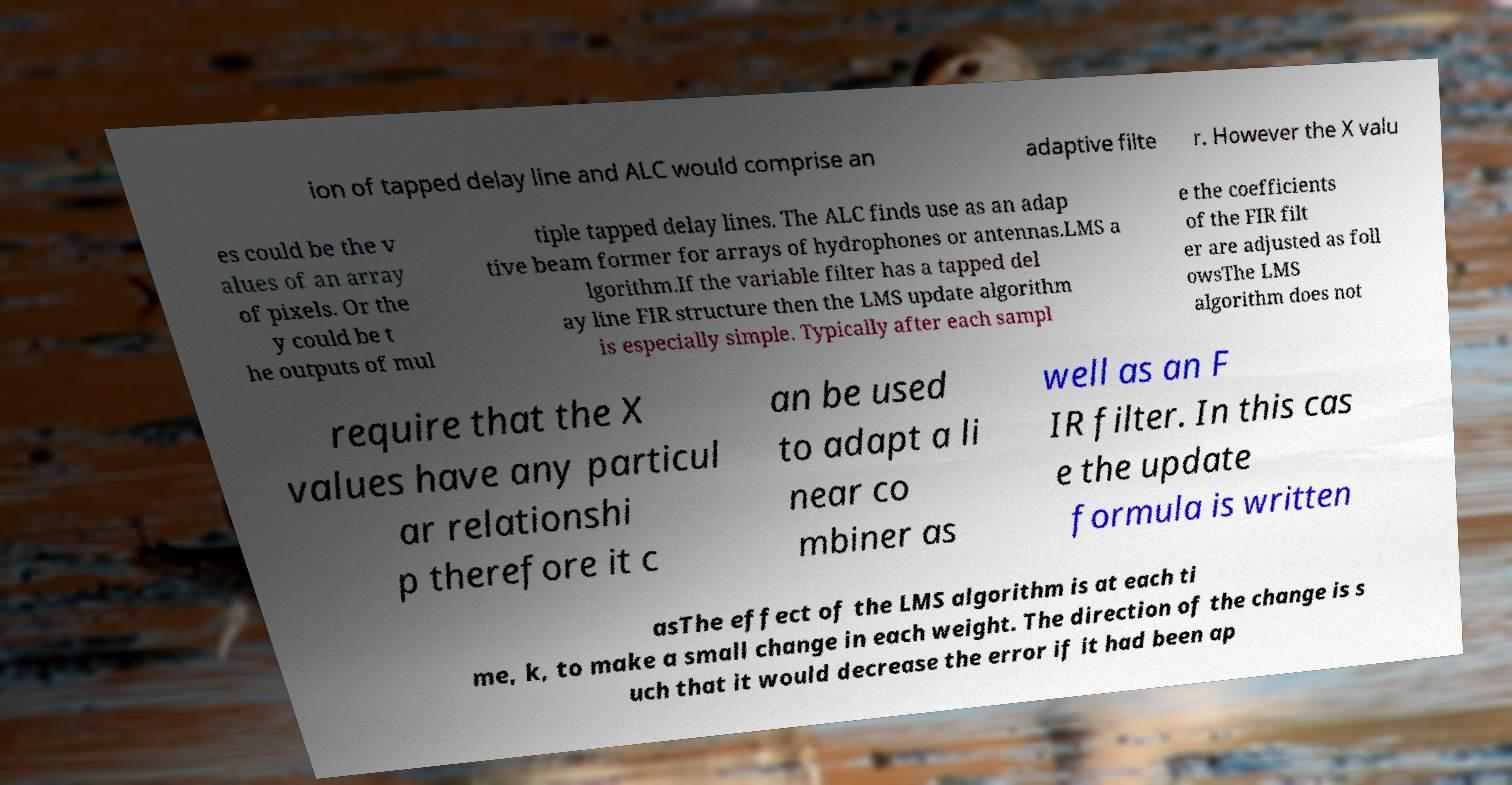I need the written content from this picture converted into text. Can you do that? ion of tapped delay line and ALC would comprise an adaptive filte r. However the X valu es could be the v alues of an array of pixels. Or the y could be t he outputs of mul tiple tapped delay lines. The ALC finds use as an adap tive beam former for arrays of hydrophones or antennas.LMS a lgorithm.If the variable filter has a tapped del ay line FIR structure then the LMS update algorithm is especially simple. Typically after each sampl e the coefficients of the FIR filt er are adjusted as foll owsThe LMS algorithm does not require that the X values have any particul ar relationshi p therefore it c an be used to adapt a li near co mbiner as well as an F IR filter. In this cas e the update formula is written asThe effect of the LMS algorithm is at each ti me, k, to make a small change in each weight. The direction of the change is s uch that it would decrease the error if it had been ap 